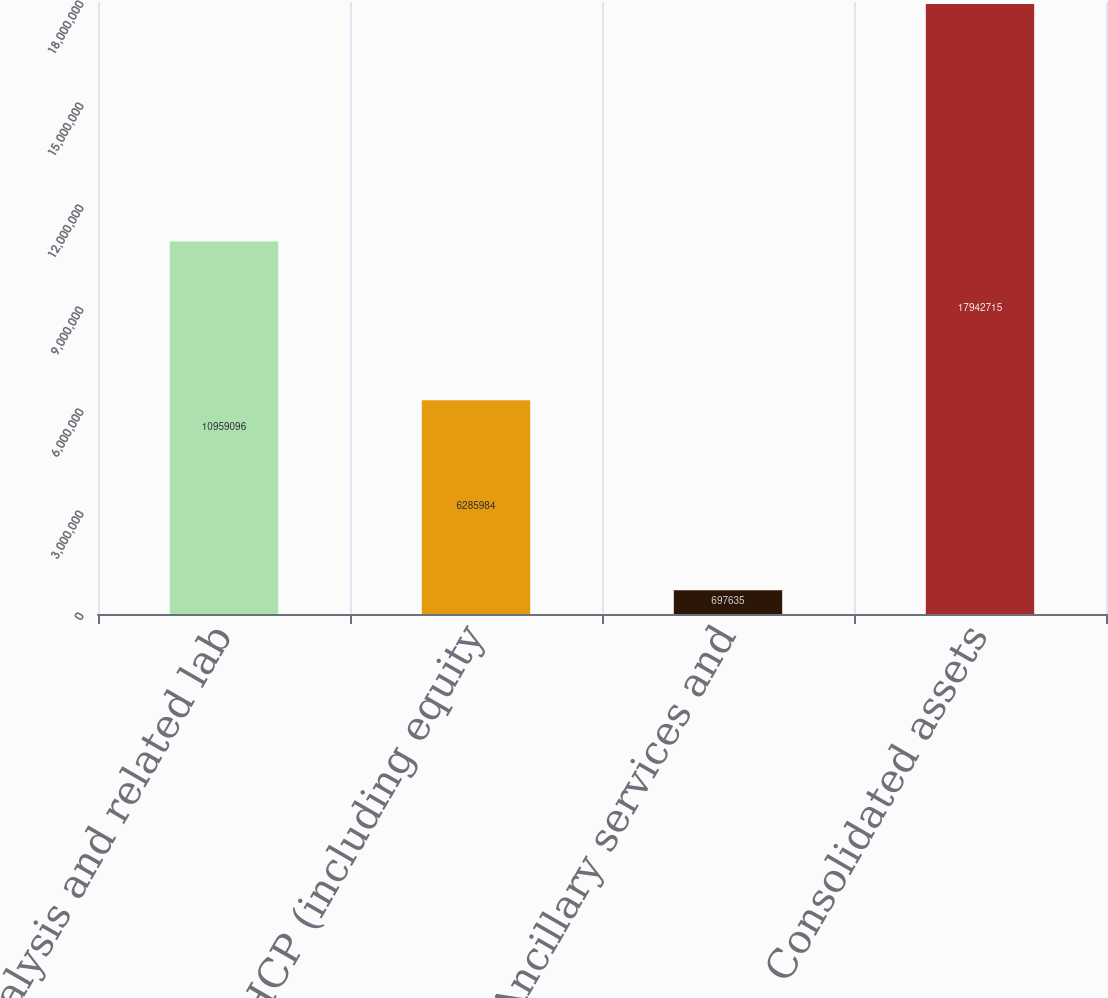Convert chart to OTSL. <chart><loc_0><loc_0><loc_500><loc_500><bar_chart><fcel>US dialysis and related lab<fcel>HCP (including equity<fcel>Other-Ancillary services and<fcel>Consolidated assets<nl><fcel>1.09591e+07<fcel>6.28598e+06<fcel>697635<fcel>1.79427e+07<nl></chart> 